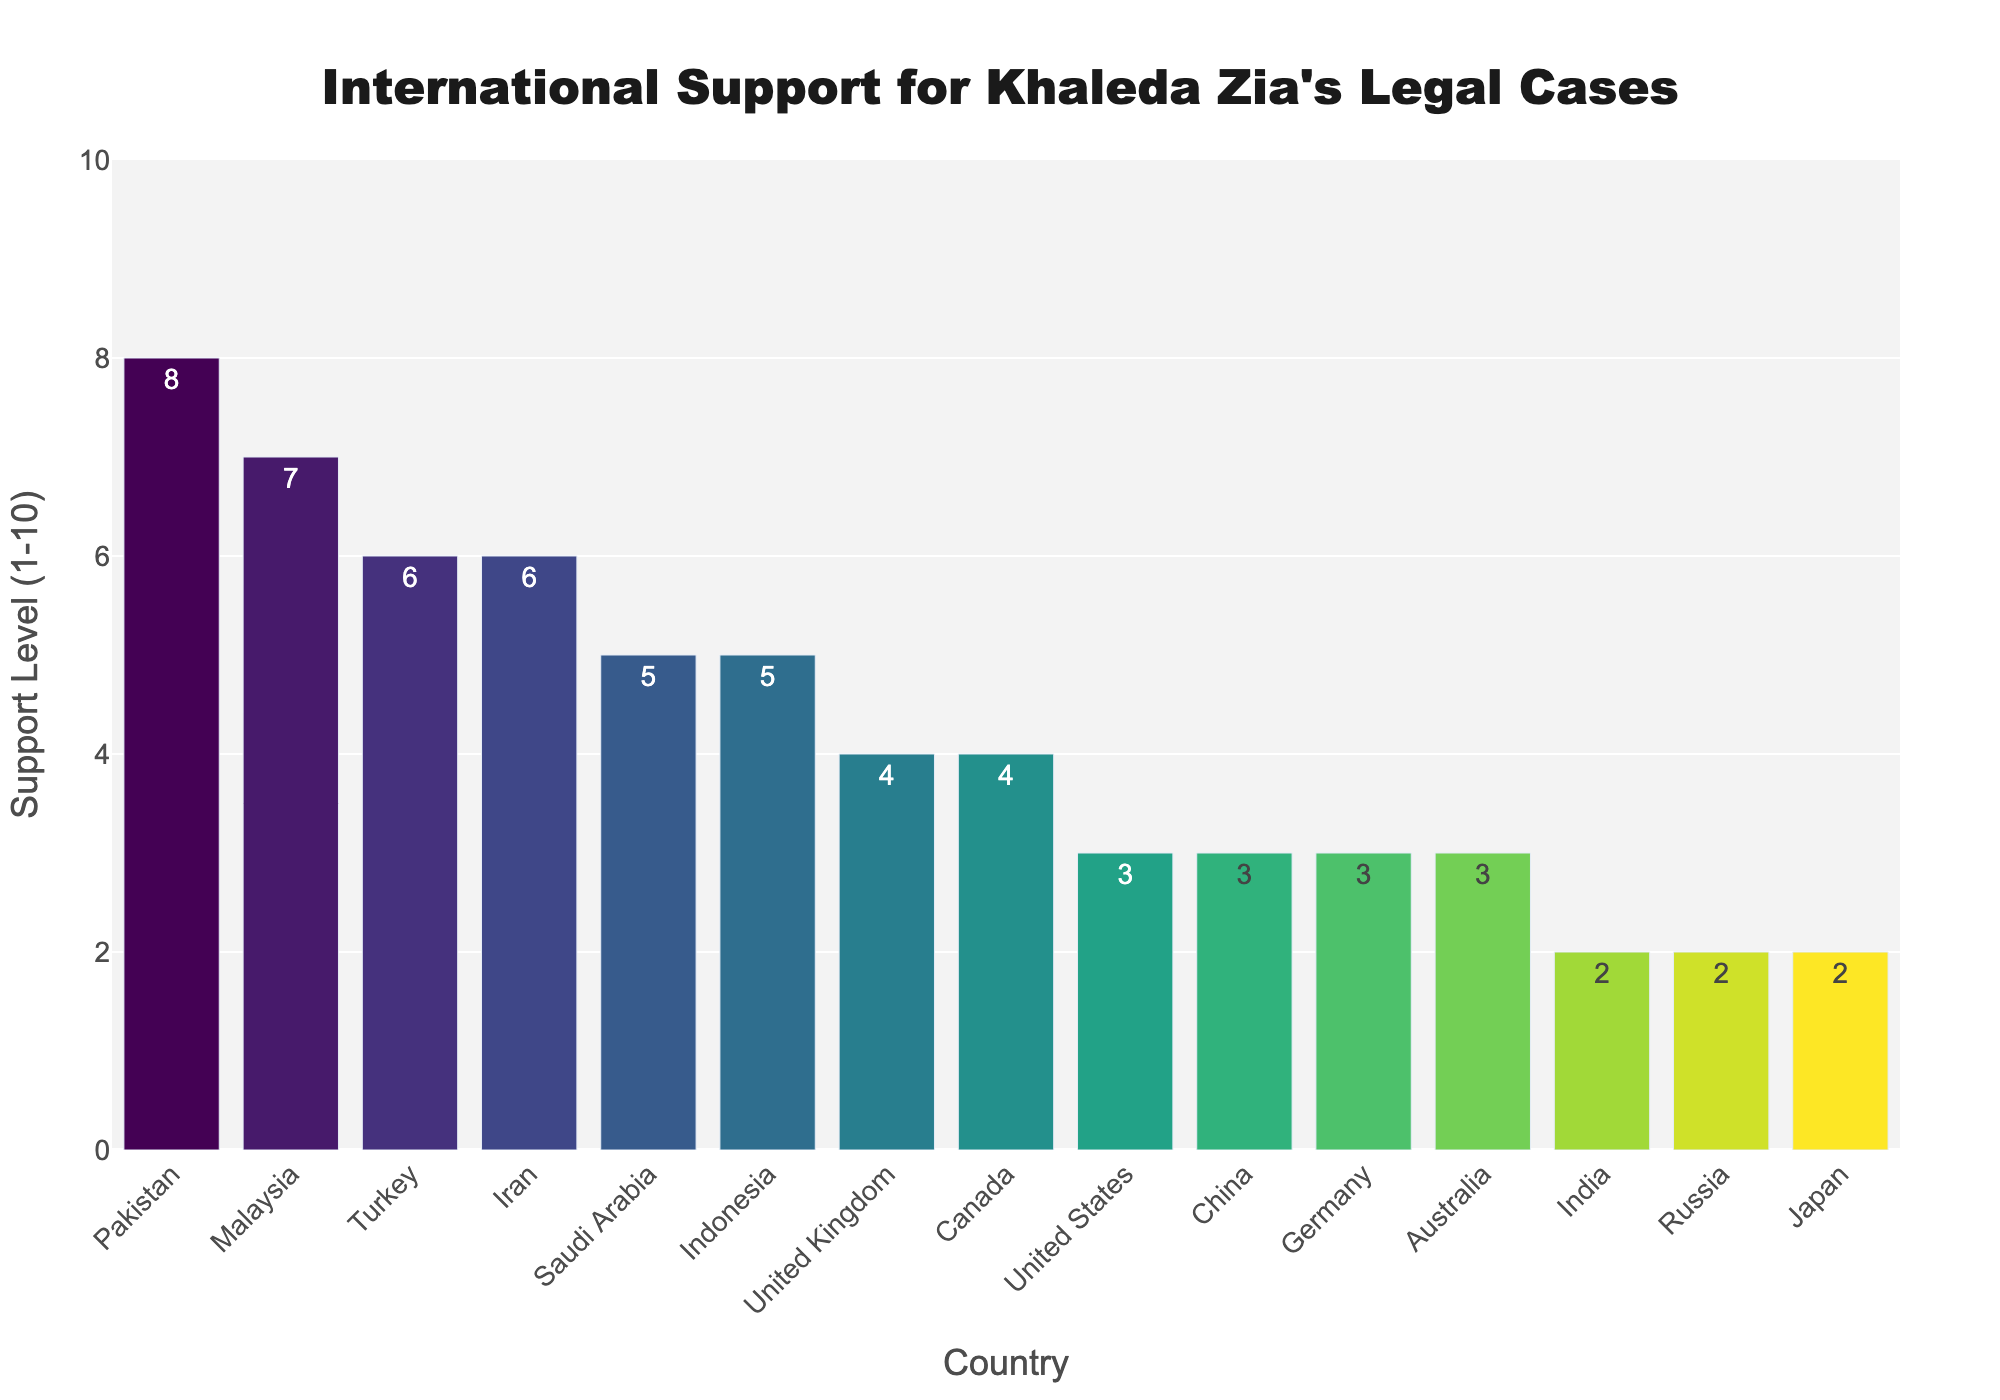Which country shows the highest level of support for Khaleda Zia's legal cases? The highest bar on the chart represents Pakistan, which has a support level of 8, making it the country with the highest level of support.
Answer: Pakistan Which countries have a support level of 2 for Khaleda Zia according to the chart? By examining the chart, we look for the bars with the value of 2 on the y-axis. The two countries represented by these bars are India and Russia.
Answer: India, Russia Which countries show a higher support level than the United States? The United States has a support level of 3. The countries with higher support levels are Malaysia, Pakistan, Turkey, Iran, Saudi Arabia, and Indonesia.
Answer: Malaysia, Pakistan, Turkey, Iran, Saudi Arabia, Indonesia What is the combined support level of Turkey and Iran? Turkey has a support level of 6, and Iran also has a support level of 6. Thus, their combined support level is 6 + 6 = 12.
Answer: 12 Which country has the lowest support for Khaleda Zia, and what is their support level? The countries with the lowest support level, which is 2, are India, Russia, and Japan.
Answer: India, Russia, Japan Which country has exactly 7 as its support level and what rank does it hold in the sorted list from highest to lowest support? Malaysia has a support level of 7. When sorted from highest to lowest, Malaysia is the second-highest ranked country after Pakistan.
Answer: Malaysia, 2 How many countries have a support level equal to or greater than 5? By counting the bars with a value of 5 or greater, there are six countries: Pakistan (8), Malaysia (7), Turkey (6), Iran (6), Saudi Arabia (5), and Indonesia (5).
Answer: 6 Are there more countries with a support level greater than 4 or less than or equal to 4? Six countries have support levels greater than 4 (Malaysia, Pakistan, Turkey, Iran, Saudi Arabia, Indonesia), and nine countries have support levels less than or equal to 4 (India, United States, United Kingdom, China, Russia, Germany, Canada, Australia, Japan).
Answer: Less than or equal to 4 Which country has just one support level greater than Malaysia, and what is that level? Pakistan has a support level of 8, which is just one level higher than Malaysia's support level of 7.
Answer: Pakistan, 8 